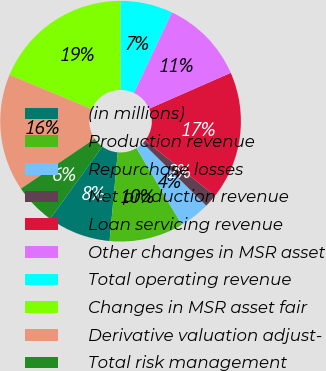Convert chart. <chart><loc_0><loc_0><loc_500><loc_500><pie_chart><fcel>(in millions)<fcel>Production revenue<fcel>Repurchase losses<fcel>Net production revenue<fcel>Loan servicing revenue<fcel>Other changes in MSR asset<fcel>Total operating revenue<fcel>Changes in MSR asset fair<fcel>Derivative valuation adjust-<fcel>Total risk management<nl><fcel>8.49%<fcel>9.95%<fcel>4.12%<fcel>1.75%<fcel>17.22%<fcel>11.4%<fcel>7.04%<fcel>18.68%<fcel>15.77%<fcel>5.58%<nl></chart> 